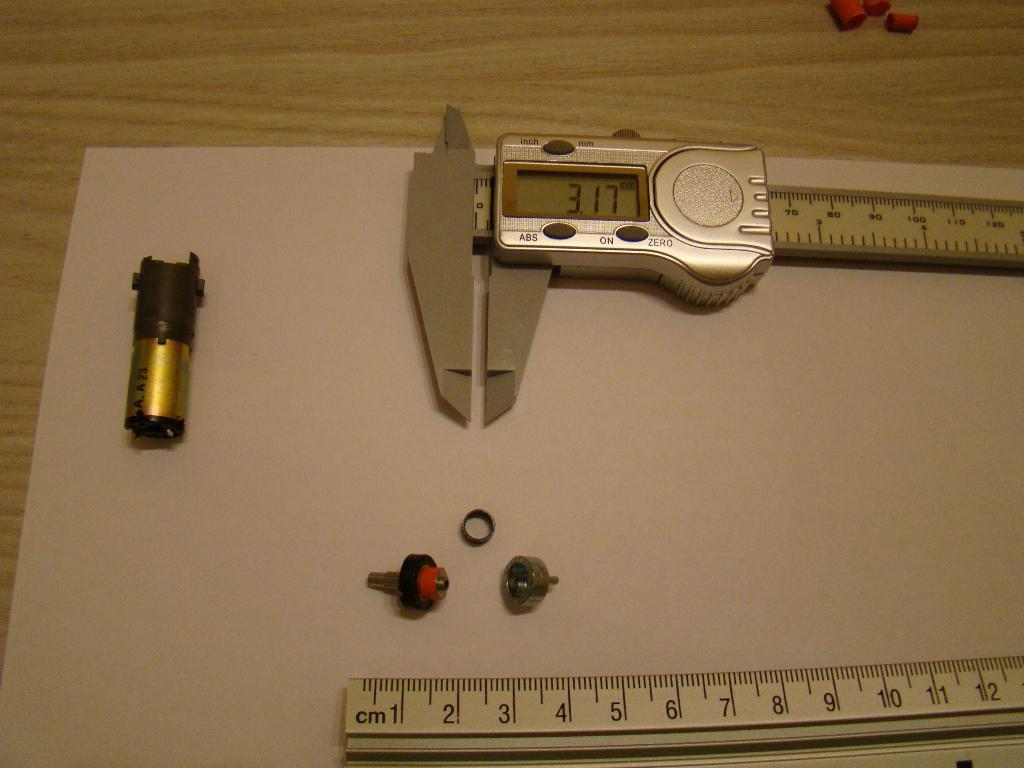<image>
Write a terse but informative summary of the picture. the numbers 7 and 7 are on a ruler 